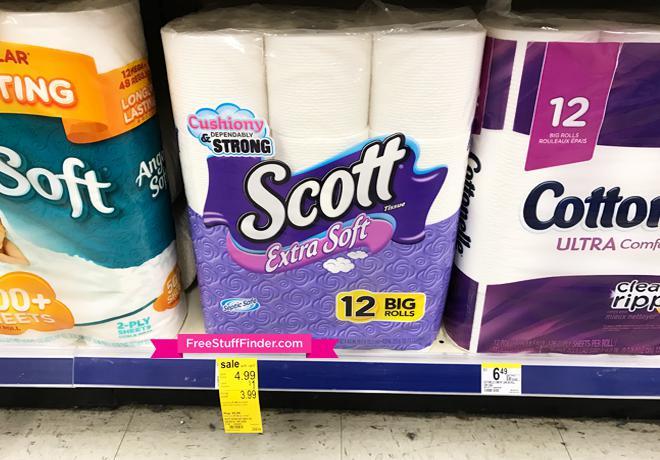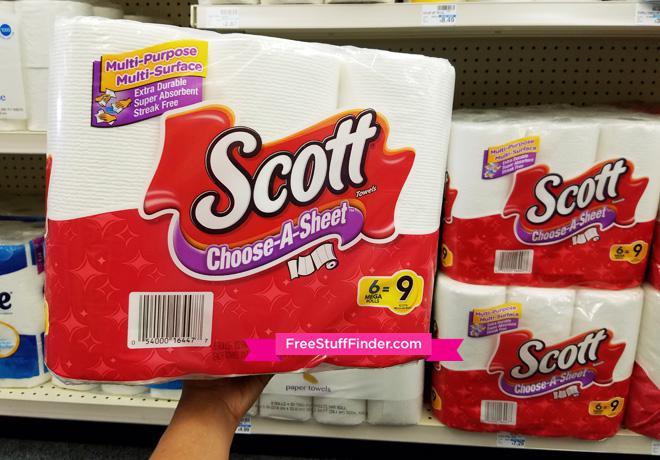The first image is the image on the left, the second image is the image on the right. Given the left and right images, does the statement "In at least one image there is a 6 pack of scott paper towel sitting on a store shelve in mostly red packaging." hold true? Answer yes or no. Yes. The first image is the image on the left, the second image is the image on the right. Given the left and right images, does the statement "The right image shows multipacks of paper towels on a store shelf, and includes a pack with the bottom half red." hold true? Answer yes or no. Yes. 